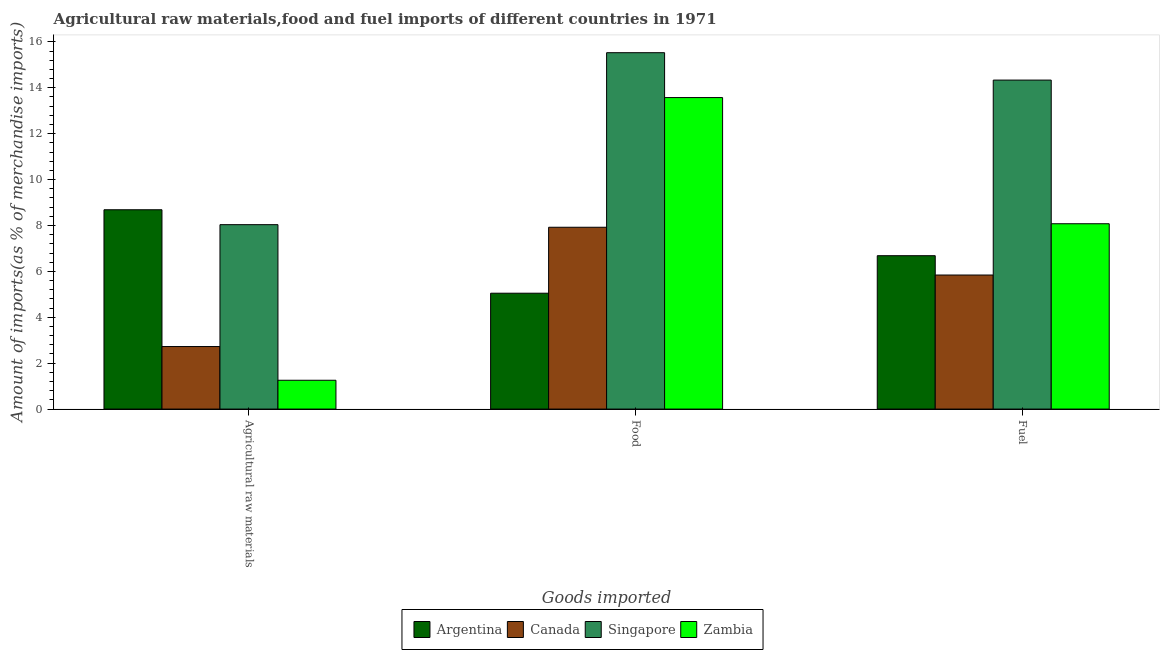How many different coloured bars are there?
Give a very brief answer. 4. How many groups of bars are there?
Offer a very short reply. 3. Are the number of bars per tick equal to the number of legend labels?
Your answer should be compact. Yes. How many bars are there on the 3rd tick from the right?
Offer a very short reply. 4. What is the label of the 2nd group of bars from the left?
Give a very brief answer. Food. What is the percentage of food imports in Canada?
Keep it short and to the point. 7.92. Across all countries, what is the maximum percentage of raw materials imports?
Give a very brief answer. 8.68. Across all countries, what is the minimum percentage of food imports?
Your response must be concise. 5.05. What is the total percentage of fuel imports in the graph?
Offer a very short reply. 34.93. What is the difference between the percentage of food imports in Singapore and that in Canada?
Offer a very short reply. 7.61. What is the difference between the percentage of fuel imports in Zambia and the percentage of raw materials imports in Argentina?
Keep it short and to the point. -0.61. What is the average percentage of fuel imports per country?
Your answer should be compact. 8.73. What is the difference between the percentage of food imports and percentage of fuel imports in Singapore?
Keep it short and to the point. 1.19. In how many countries, is the percentage of raw materials imports greater than 5.6 %?
Provide a succinct answer. 2. What is the ratio of the percentage of food imports in Singapore to that in Zambia?
Provide a succinct answer. 1.14. Is the percentage of raw materials imports in Canada less than that in Zambia?
Your answer should be compact. No. Is the difference between the percentage of raw materials imports in Singapore and Canada greater than the difference between the percentage of fuel imports in Singapore and Canada?
Offer a very short reply. No. What is the difference between the highest and the second highest percentage of raw materials imports?
Provide a succinct answer. 0.65. What is the difference between the highest and the lowest percentage of fuel imports?
Provide a short and direct response. 8.49. In how many countries, is the percentage of fuel imports greater than the average percentage of fuel imports taken over all countries?
Provide a succinct answer. 1. What does the 2nd bar from the left in Agricultural raw materials represents?
Your answer should be very brief. Canada. What does the 4th bar from the right in Food represents?
Your response must be concise. Argentina. How many bars are there?
Make the answer very short. 12. How many countries are there in the graph?
Your answer should be compact. 4. What is the difference between two consecutive major ticks on the Y-axis?
Provide a succinct answer. 2. Are the values on the major ticks of Y-axis written in scientific E-notation?
Offer a very short reply. No. Where does the legend appear in the graph?
Provide a succinct answer. Bottom center. What is the title of the graph?
Offer a terse response. Agricultural raw materials,food and fuel imports of different countries in 1971. What is the label or title of the X-axis?
Offer a very short reply. Goods imported. What is the label or title of the Y-axis?
Offer a terse response. Amount of imports(as % of merchandise imports). What is the Amount of imports(as % of merchandise imports) of Argentina in Agricultural raw materials?
Make the answer very short. 8.68. What is the Amount of imports(as % of merchandise imports) in Canada in Agricultural raw materials?
Ensure brevity in your answer.  2.72. What is the Amount of imports(as % of merchandise imports) in Singapore in Agricultural raw materials?
Offer a terse response. 8.04. What is the Amount of imports(as % of merchandise imports) of Zambia in Agricultural raw materials?
Provide a short and direct response. 1.26. What is the Amount of imports(as % of merchandise imports) of Argentina in Food?
Provide a succinct answer. 5.05. What is the Amount of imports(as % of merchandise imports) in Canada in Food?
Your response must be concise. 7.92. What is the Amount of imports(as % of merchandise imports) in Singapore in Food?
Ensure brevity in your answer.  15.53. What is the Amount of imports(as % of merchandise imports) of Zambia in Food?
Provide a short and direct response. 13.57. What is the Amount of imports(as % of merchandise imports) in Argentina in Fuel?
Provide a succinct answer. 6.68. What is the Amount of imports(as % of merchandise imports) of Canada in Fuel?
Offer a very short reply. 5.84. What is the Amount of imports(as % of merchandise imports) of Singapore in Fuel?
Ensure brevity in your answer.  14.33. What is the Amount of imports(as % of merchandise imports) of Zambia in Fuel?
Give a very brief answer. 8.07. Across all Goods imported, what is the maximum Amount of imports(as % of merchandise imports) of Argentina?
Provide a short and direct response. 8.68. Across all Goods imported, what is the maximum Amount of imports(as % of merchandise imports) of Canada?
Your answer should be compact. 7.92. Across all Goods imported, what is the maximum Amount of imports(as % of merchandise imports) of Singapore?
Offer a very short reply. 15.53. Across all Goods imported, what is the maximum Amount of imports(as % of merchandise imports) of Zambia?
Keep it short and to the point. 13.57. Across all Goods imported, what is the minimum Amount of imports(as % of merchandise imports) of Argentina?
Provide a short and direct response. 5.05. Across all Goods imported, what is the minimum Amount of imports(as % of merchandise imports) of Canada?
Offer a very short reply. 2.72. Across all Goods imported, what is the minimum Amount of imports(as % of merchandise imports) of Singapore?
Make the answer very short. 8.04. Across all Goods imported, what is the minimum Amount of imports(as % of merchandise imports) in Zambia?
Offer a very short reply. 1.26. What is the total Amount of imports(as % of merchandise imports) in Argentina in the graph?
Ensure brevity in your answer.  20.42. What is the total Amount of imports(as % of merchandise imports) of Canada in the graph?
Provide a succinct answer. 16.49. What is the total Amount of imports(as % of merchandise imports) in Singapore in the graph?
Provide a short and direct response. 37.9. What is the total Amount of imports(as % of merchandise imports) of Zambia in the graph?
Your response must be concise. 22.9. What is the difference between the Amount of imports(as % of merchandise imports) of Argentina in Agricultural raw materials and that in Food?
Ensure brevity in your answer.  3.64. What is the difference between the Amount of imports(as % of merchandise imports) in Canada in Agricultural raw materials and that in Food?
Keep it short and to the point. -5.2. What is the difference between the Amount of imports(as % of merchandise imports) in Singapore in Agricultural raw materials and that in Food?
Keep it short and to the point. -7.49. What is the difference between the Amount of imports(as % of merchandise imports) of Zambia in Agricultural raw materials and that in Food?
Your answer should be compact. -12.32. What is the difference between the Amount of imports(as % of merchandise imports) in Argentina in Agricultural raw materials and that in Fuel?
Provide a short and direct response. 2. What is the difference between the Amount of imports(as % of merchandise imports) in Canada in Agricultural raw materials and that in Fuel?
Keep it short and to the point. -3.12. What is the difference between the Amount of imports(as % of merchandise imports) in Singapore in Agricultural raw materials and that in Fuel?
Ensure brevity in your answer.  -6.3. What is the difference between the Amount of imports(as % of merchandise imports) in Zambia in Agricultural raw materials and that in Fuel?
Give a very brief answer. -6.82. What is the difference between the Amount of imports(as % of merchandise imports) of Argentina in Food and that in Fuel?
Give a very brief answer. -1.63. What is the difference between the Amount of imports(as % of merchandise imports) in Canada in Food and that in Fuel?
Offer a terse response. 2.08. What is the difference between the Amount of imports(as % of merchandise imports) in Singapore in Food and that in Fuel?
Your answer should be very brief. 1.19. What is the difference between the Amount of imports(as % of merchandise imports) of Zambia in Food and that in Fuel?
Your answer should be very brief. 5.5. What is the difference between the Amount of imports(as % of merchandise imports) of Argentina in Agricultural raw materials and the Amount of imports(as % of merchandise imports) of Canada in Food?
Your answer should be very brief. 0.76. What is the difference between the Amount of imports(as % of merchandise imports) of Argentina in Agricultural raw materials and the Amount of imports(as % of merchandise imports) of Singapore in Food?
Ensure brevity in your answer.  -6.84. What is the difference between the Amount of imports(as % of merchandise imports) in Argentina in Agricultural raw materials and the Amount of imports(as % of merchandise imports) in Zambia in Food?
Your response must be concise. -4.89. What is the difference between the Amount of imports(as % of merchandise imports) of Canada in Agricultural raw materials and the Amount of imports(as % of merchandise imports) of Singapore in Food?
Provide a succinct answer. -12.8. What is the difference between the Amount of imports(as % of merchandise imports) in Canada in Agricultural raw materials and the Amount of imports(as % of merchandise imports) in Zambia in Food?
Give a very brief answer. -10.85. What is the difference between the Amount of imports(as % of merchandise imports) of Singapore in Agricultural raw materials and the Amount of imports(as % of merchandise imports) of Zambia in Food?
Ensure brevity in your answer.  -5.54. What is the difference between the Amount of imports(as % of merchandise imports) of Argentina in Agricultural raw materials and the Amount of imports(as % of merchandise imports) of Canada in Fuel?
Your response must be concise. 2.84. What is the difference between the Amount of imports(as % of merchandise imports) in Argentina in Agricultural raw materials and the Amount of imports(as % of merchandise imports) in Singapore in Fuel?
Your answer should be very brief. -5.65. What is the difference between the Amount of imports(as % of merchandise imports) in Argentina in Agricultural raw materials and the Amount of imports(as % of merchandise imports) in Zambia in Fuel?
Provide a short and direct response. 0.61. What is the difference between the Amount of imports(as % of merchandise imports) in Canada in Agricultural raw materials and the Amount of imports(as % of merchandise imports) in Singapore in Fuel?
Make the answer very short. -11.61. What is the difference between the Amount of imports(as % of merchandise imports) in Canada in Agricultural raw materials and the Amount of imports(as % of merchandise imports) in Zambia in Fuel?
Provide a succinct answer. -5.35. What is the difference between the Amount of imports(as % of merchandise imports) in Singapore in Agricultural raw materials and the Amount of imports(as % of merchandise imports) in Zambia in Fuel?
Ensure brevity in your answer.  -0.04. What is the difference between the Amount of imports(as % of merchandise imports) of Argentina in Food and the Amount of imports(as % of merchandise imports) of Canada in Fuel?
Your answer should be compact. -0.79. What is the difference between the Amount of imports(as % of merchandise imports) of Argentina in Food and the Amount of imports(as % of merchandise imports) of Singapore in Fuel?
Your answer should be compact. -9.29. What is the difference between the Amount of imports(as % of merchandise imports) in Argentina in Food and the Amount of imports(as % of merchandise imports) in Zambia in Fuel?
Ensure brevity in your answer.  -3.03. What is the difference between the Amount of imports(as % of merchandise imports) of Canada in Food and the Amount of imports(as % of merchandise imports) of Singapore in Fuel?
Make the answer very short. -6.41. What is the difference between the Amount of imports(as % of merchandise imports) of Canada in Food and the Amount of imports(as % of merchandise imports) of Zambia in Fuel?
Ensure brevity in your answer.  -0.15. What is the difference between the Amount of imports(as % of merchandise imports) of Singapore in Food and the Amount of imports(as % of merchandise imports) of Zambia in Fuel?
Give a very brief answer. 7.45. What is the average Amount of imports(as % of merchandise imports) in Argentina per Goods imported?
Make the answer very short. 6.81. What is the average Amount of imports(as % of merchandise imports) of Canada per Goods imported?
Offer a terse response. 5.5. What is the average Amount of imports(as % of merchandise imports) in Singapore per Goods imported?
Offer a very short reply. 12.63. What is the average Amount of imports(as % of merchandise imports) in Zambia per Goods imported?
Offer a very short reply. 7.63. What is the difference between the Amount of imports(as % of merchandise imports) of Argentina and Amount of imports(as % of merchandise imports) of Canada in Agricultural raw materials?
Your answer should be compact. 5.96. What is the difference between the Amount of imports(as % of merchandise imports) of Argentina and Amount of imports(as % of merchandise imports) of Singapore in Agricultural raw materials?
Provide a short and direct response. 0.65. What is the difference between the Amount of imports(as % of merchandise imports) of Argentina and Amount of imports(as % of merchandise imports) of Zambia in Agricultural raw materials?
Offer a terse response. 7.43. What is the difference between the Amount of imports(as % of merchandise imports) in Canada and Amount of imports(as % of merchandise imports) in Singapore in Agricultural raw materials?
Make the answer very short. -5.31. What is the difference between the Amount of imports(as % of merchandise imports) of Canada and Amount of imports(as % of merchandise imports) of Zambia in Agricultural raw materials?
Your answer should be compact. 1.47. What is the difference between the Amount of imports(as % of merchandise imports) in Singapore and Amount of imports(as % of merchandise imports) in Zambia in Agricultural raw materials?
Your answer should be compact. 6.78. What is the difference between the Amount of imports(as % of merchandise imports) of Argentina and Amount of imports(as % of merchandise imports) of Canada in Food?
Ensure brevity in your answer.  -2.87. What is the difference between the Amount of imports(as % of merchandise imports) in Argentina and Amount of imports(as % of merchandise imports) in Singapore in Food?
Ensure brevity in your answer.  -10.48. What is the difference between the Amount of imports(as % of merchandise imports) in Argentina and Amount of imports(as % of merchandise imports) in Zambia in Food?
Make the answer very short. -8.52. What is the difference between the Amount of imports(as % of merchandise imports) in Canada and Amount of imports(as % of merchandise imports) in Singapore in Food?
Offer a terse response. -7.61. What is the difference between the Amount of imports(as % of merchandise imports) in Canada and Amount of imports(as % of merchandise imports) in Zambia in Food?
Make the answer very short. -5.65. What is the difference between the Amount of imports(as % of merchandise imports) in Singapore and Amount of imports(as % of merchandise imports) in Zambia in Food?
Provide a short and direct response. 1.96. What is the difference between the Amount of imports(as % of merchandise imports) in Argentina and Amount of imports(as % of merchandise imports) in Canada in Fuel?
Make the answer very short. 0.84. What is the difference between the Amount of imports(as % of merchandise imports) of Argentina and Amount of imports(as % of merchandise imports) of Singapore in Fuel?
Keep it short and to the point. -7.65. What is the difference between the Amount of imports(as % of merchandise imports) of Argentina and Amount of imports(as % of merchandise imports) of Zambia in Fuel?
Make the answer very short. -1.39. What is the difference between the Amount of imports(as % of merchandise imports) of Canada and Amount of imports(as % of merchandise imports) of Singapore in Fuel?
Ensure brevity in your answer.  -8.49. What is the difference between the Amount of imports(as % of merchandise imports) in Canada and Amount of imports(as % of merchandise imports) in Zambia in Fuel?
Your answer should be very brief. -2.23. What is the difference between the Amount of imports(as % of merchandise imports) of Singapore and Amount of imports(as % of merchandise imports) of Zambia in Fuel?
Provide a short and direct response. 6.26. What is the ratio of the Amount of imports(as % of merchandise imports) in Argentina in Agricultural raw materials to that in Food?
Your answer should be compact. 1.72. What is the ratio of the Amount of imports(as % of merchandise imports) of Canada in Agricultural raw materials to that in Food?
Your answer should be compact. 0.34. What is the ratio of the Amount of imports(as % of merchandise imports) of Singapore in Agricultural raw materials to that in Food?
Ensure brevity in your answer.  0.52. What is the ratio of the Amount of imports(as % of merchandise imports) in Zambia in Agricultural raw materials to that in Food?
Provide a short and direct response. 0.09. What is the ratio of the Amount of imports(as % of merchandise imports) in Argentina in Agricultural raw materials to that in Fuel?
Give a very brief answer. 1.3. What is the ratio of the Amount of imports(as % of merchandise imports) in Canada in Agricultural raw materials to that in Fuel?
Make the answer very short. 0.47. What is the ratio of the Amount of imports(as % of merchandise imports) of Singapore in Agricultural raw materials to that in Fuel?
Offer a terse response. 0.56. What is the ratio of the Amount of imports(as % of merchandise imports) in Zambia in Agricultural raw materials to that in Fuel?
Your response must be concise. 0.16. What is the ratio of the Amount of imports(as % of merchandise imports) in Argentina in Food to that in Fuel?
Offer a very short reply. 0.76. What is the ratio of the Amount of imports(as % of merchandise imports) of Canada in Food to that in Fuel?
Provide a short and direct response. 1.36. What is the ratio of the Amount of imports(as % of merchandise imports) of Singapore in Food to that in Fuel?
Keep it short and to the point. 1.08. What is the ratio of the Amount of imports(as % of merchandise imports) of Zambia in Food to that in Fuel?
Your answer should be very brief. 1.68. What is the difference between the highest and the second highest Amount of imports(as % of merchandise imports) in Argentina?
Make the answer very short. 2. What is the difference between the highest and the second highest Amount of imports(as % of merchandise imports) of Canada?
Make the answer very short. 2.08. What is the difference between the highest and the second highest Amount of imports(as % of merchandise imports) in Singapore?
Provide a short and direct response. 1.19. What is the difference between the highest and the second highest Amount of imports(as % of merchandise imports) of Zambia?
Give a very brief answer. 5.5. What is the difference between the highest and the lowest Amount of imports(as % of merchandise imports) in Argentina?
Your response must be concise. 3.64. What is the difference between the highest and the lowest Amount of imports(as % of merchandise imports) of Canada?
Give a very brief answer. 5.2. What is the difference between the highest and the lowest Amount of imports(as % of merchandise imports) of Singapore?
Your response must be concise. 7.49. What is the difference between the highest and the lowest Amount of imports(as % of merchandise imports) in Zambia?
Provide a succinct answer. 12.32. 